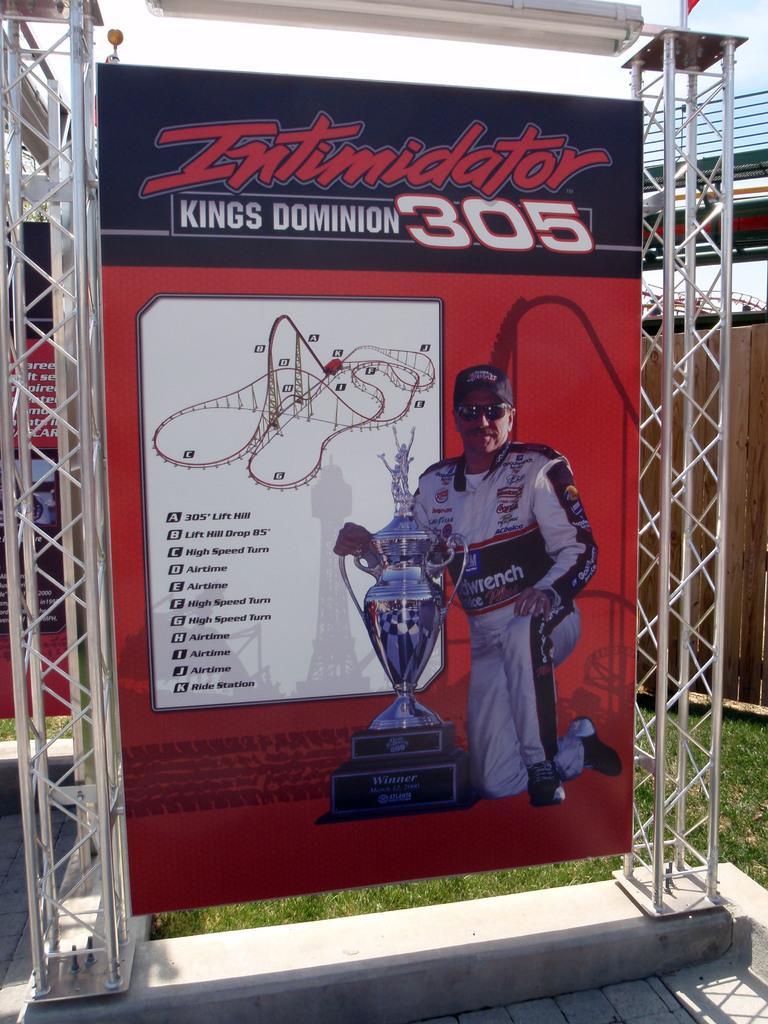<image>
Share a concise interpretation of the image provided. An Intimidator Kings Dominion 305 poster for a roller coaster with a photo a racecar champion. 